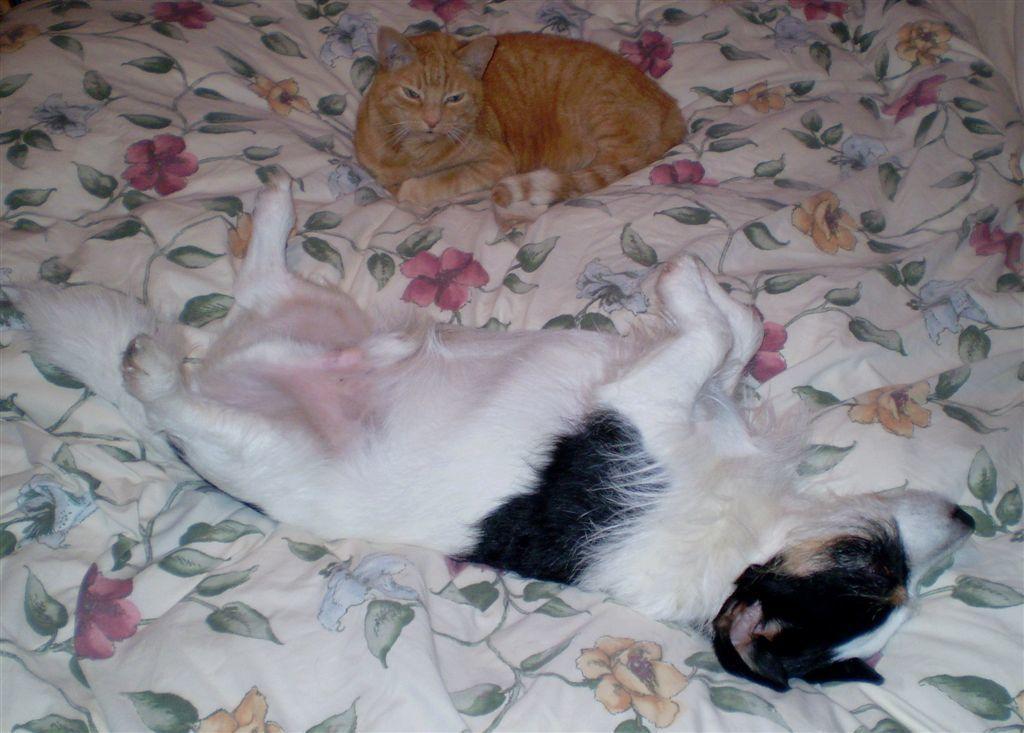How would you summarize this image in a sentence or two? In this image, we can see cats on the bed. 